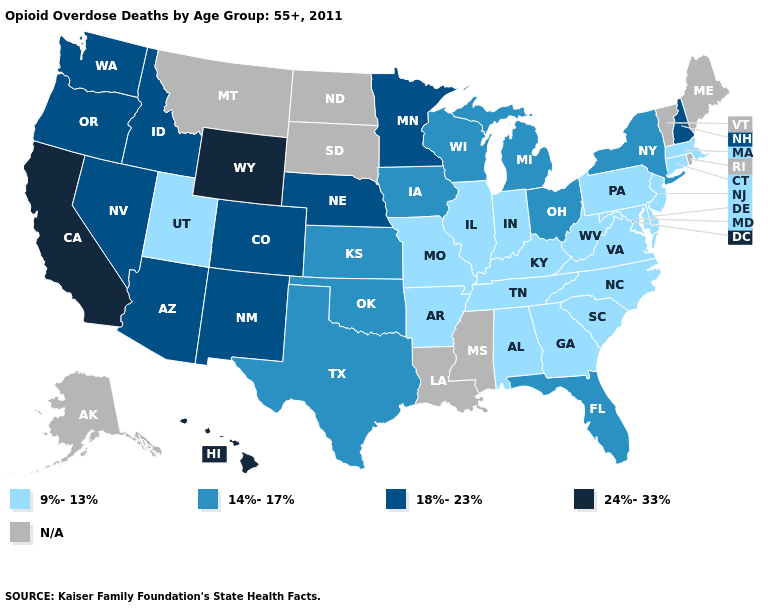Which states have the lowest value in the USA?
Short answer required. Alabama, Arkansas, Connecticut, Delaware, Georgia, Illinois, Indiana, Kentucky, Maryland, Massachusetts, Missouri, New Jersey, North Carolina, Pennsylvania, South Carolina, Tennessee, Utah, Virginia, West Virginia. Does the first symbol in the legend represent the smallest category?
Quick response, please. Yes. Name the states that have a value in the range 14%-17%?
Answer briefly. Florida, Iowa, Kansas, Michigan, New York, Ohio, Oklahoma, Texas, Wisconsin. Does Missouri have the lowest value in the MidWest?
Answer briefly. Yes. Name the states that have a value in the range 14%-17%?
Write a very short answer. Florida, Iowa, Kansas, Michigan, New York, Ohio, Oklahoma, Texas, Wisconsin. What is the lowest value in the Northeast?
Give a very brief answer. 9%-13%. What is the value of Ohio?
Give a very brief answer. 14%-17%. What is the highest value in states that border Iowa?
Keep it brief. 18%-23%. Does Oklahoma have the lowest value in the USA?
Answer briefly. No. Which states have the highest value in the USA?
Quick response, please. California, Hawaii, Wyoming. What is the value of Vermont?
Give a very brief answer. N/A. Among the states that border Delaware , which have the highest value?
Answer briefly. Maryland, New Jersey, Pennsylvania. Name the states that have a value in the range 18%-23%?
Quick response, please. Arizona, Colorado, Idaho, Minnesota, Nebraska, Nevada, New Hampshire, New Mexico, Oregon, Washington. What is the value of Alaska?
Short answer required. N/A. Does the map have missing data?
Write a very short answer. Yes. 